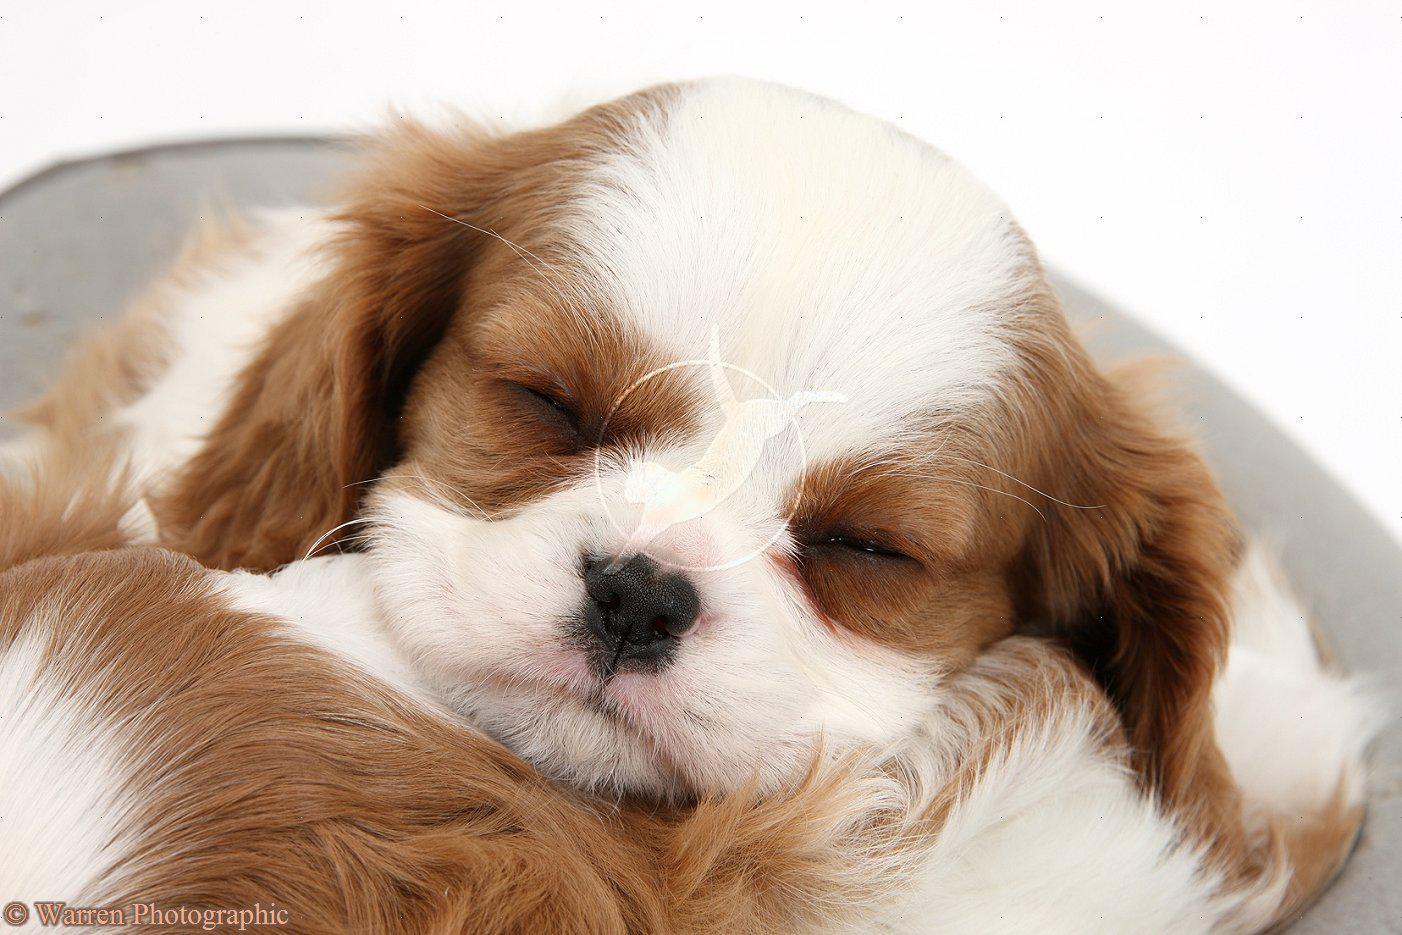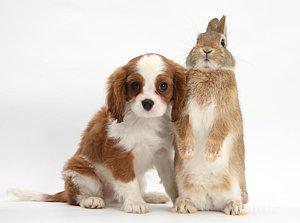The first image is the image on the left, the second image is the image on the right. Analyze the images presented: Is the assertion "There are no more than two animals" valid? Answer yes or no. No. The first image is the image on the left, the second image is the image on the right. For the images displayed, is the sentence "there are three animals." factually correct? Answer yes or no. Yes. 